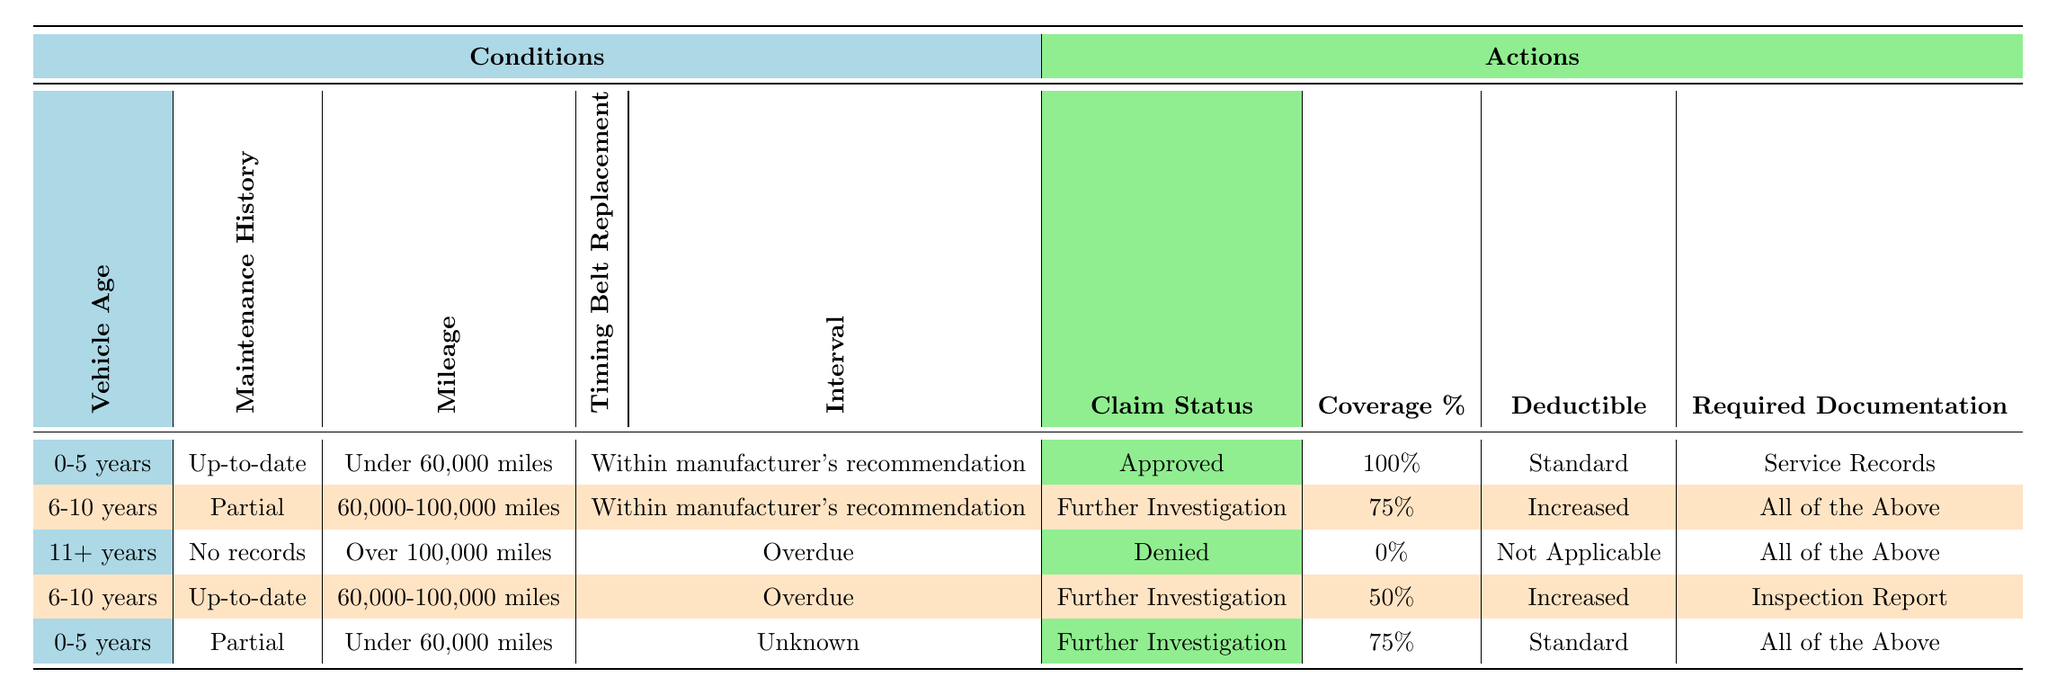What is the claim status for a vehicle aged 0-5 years with an up-to-date maintenance history and under 60,000 miles? The table indicates that for a vehicle that is 0-5 years old, with an up-to-date maintenance history, and under 60,000 miles, the claim status is "Approved".
Answer: Approved How much coverage percentage is provided for a vehicle aged 6-10 years with partial maintenance history and mileage between 60,000 and 100,000? The claim for a vehicle aged 6-10 years, which has partial maintenance history and mileage between 60,000 and 100,000, shows a coverage percentage of 75%.
Answer: 75% Is it true that a vehicle aged 11+ years with no maintenance records and over 100,000 miles is denied coverage? According to the table, this specific scenario indeed results in a claim status of "Denied", confirming the statement is true.
Answer: Yes What is the required documentation for a vehicle aged 6-10 years, up-to-date maintenance, with mileage between 60,000 and 100,000 and overdue timing belt replacement? The table specifies that for this vehicle scenario, the required documentation is an "Inspection Report".
Answer: Inspection Report What would be the average deductible if we consider all scenarios that result in further investigation? In the table, the scenarios resulting in further investigation are: 6-10 years with partial maintenance (Increased), 6-10 years with up-to-date maintenance (Increased), and 0-5 years with partial maintenance (Standard). Converting this to numerical values (Standard = 1, Increased = 2), we get (2 + 2 + 1) / 3 = 5 / 3 = 1.67. Thus, the average deductible can be stated as approximately "Standard".
Answer: Standard 